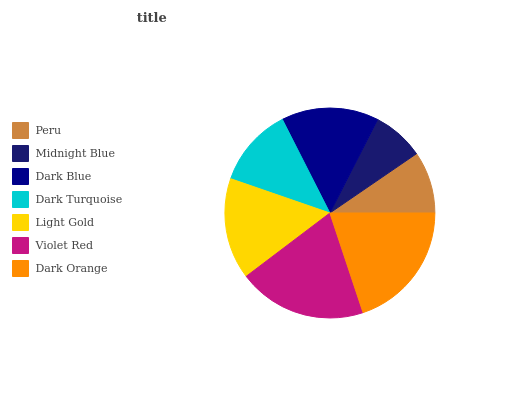Is Midnight Blue the minimum?
Answer yes or no. Yes. Is Dark Orange the maximum?
Answer yes or no. Yes. Is Dark Blue the minimum?
Answer yes or no. No. Is Dark Blue the maximum?
Answer yes or no. No. Is Dark Blue greater than Midnight Blue?
Answer yes or no. Yes. Is Midnight Blue less than Dark Blue?
Answer yes or no. Yes. Is Midnight Blue greater than Dark Blue?
Answer yes or no. No. Is Dark Blue less than Midnight Blue?
Answer yes or no. No. Is Dark Blue the high median?
Answer yes or no. Yes. Is Dark Blue the low median?
Answer yes or no. Yes. Is Dark Turquoise the high median?
Answer yes or no. No. Is Midnight Blue the low median?
Answer yes or no. No. 